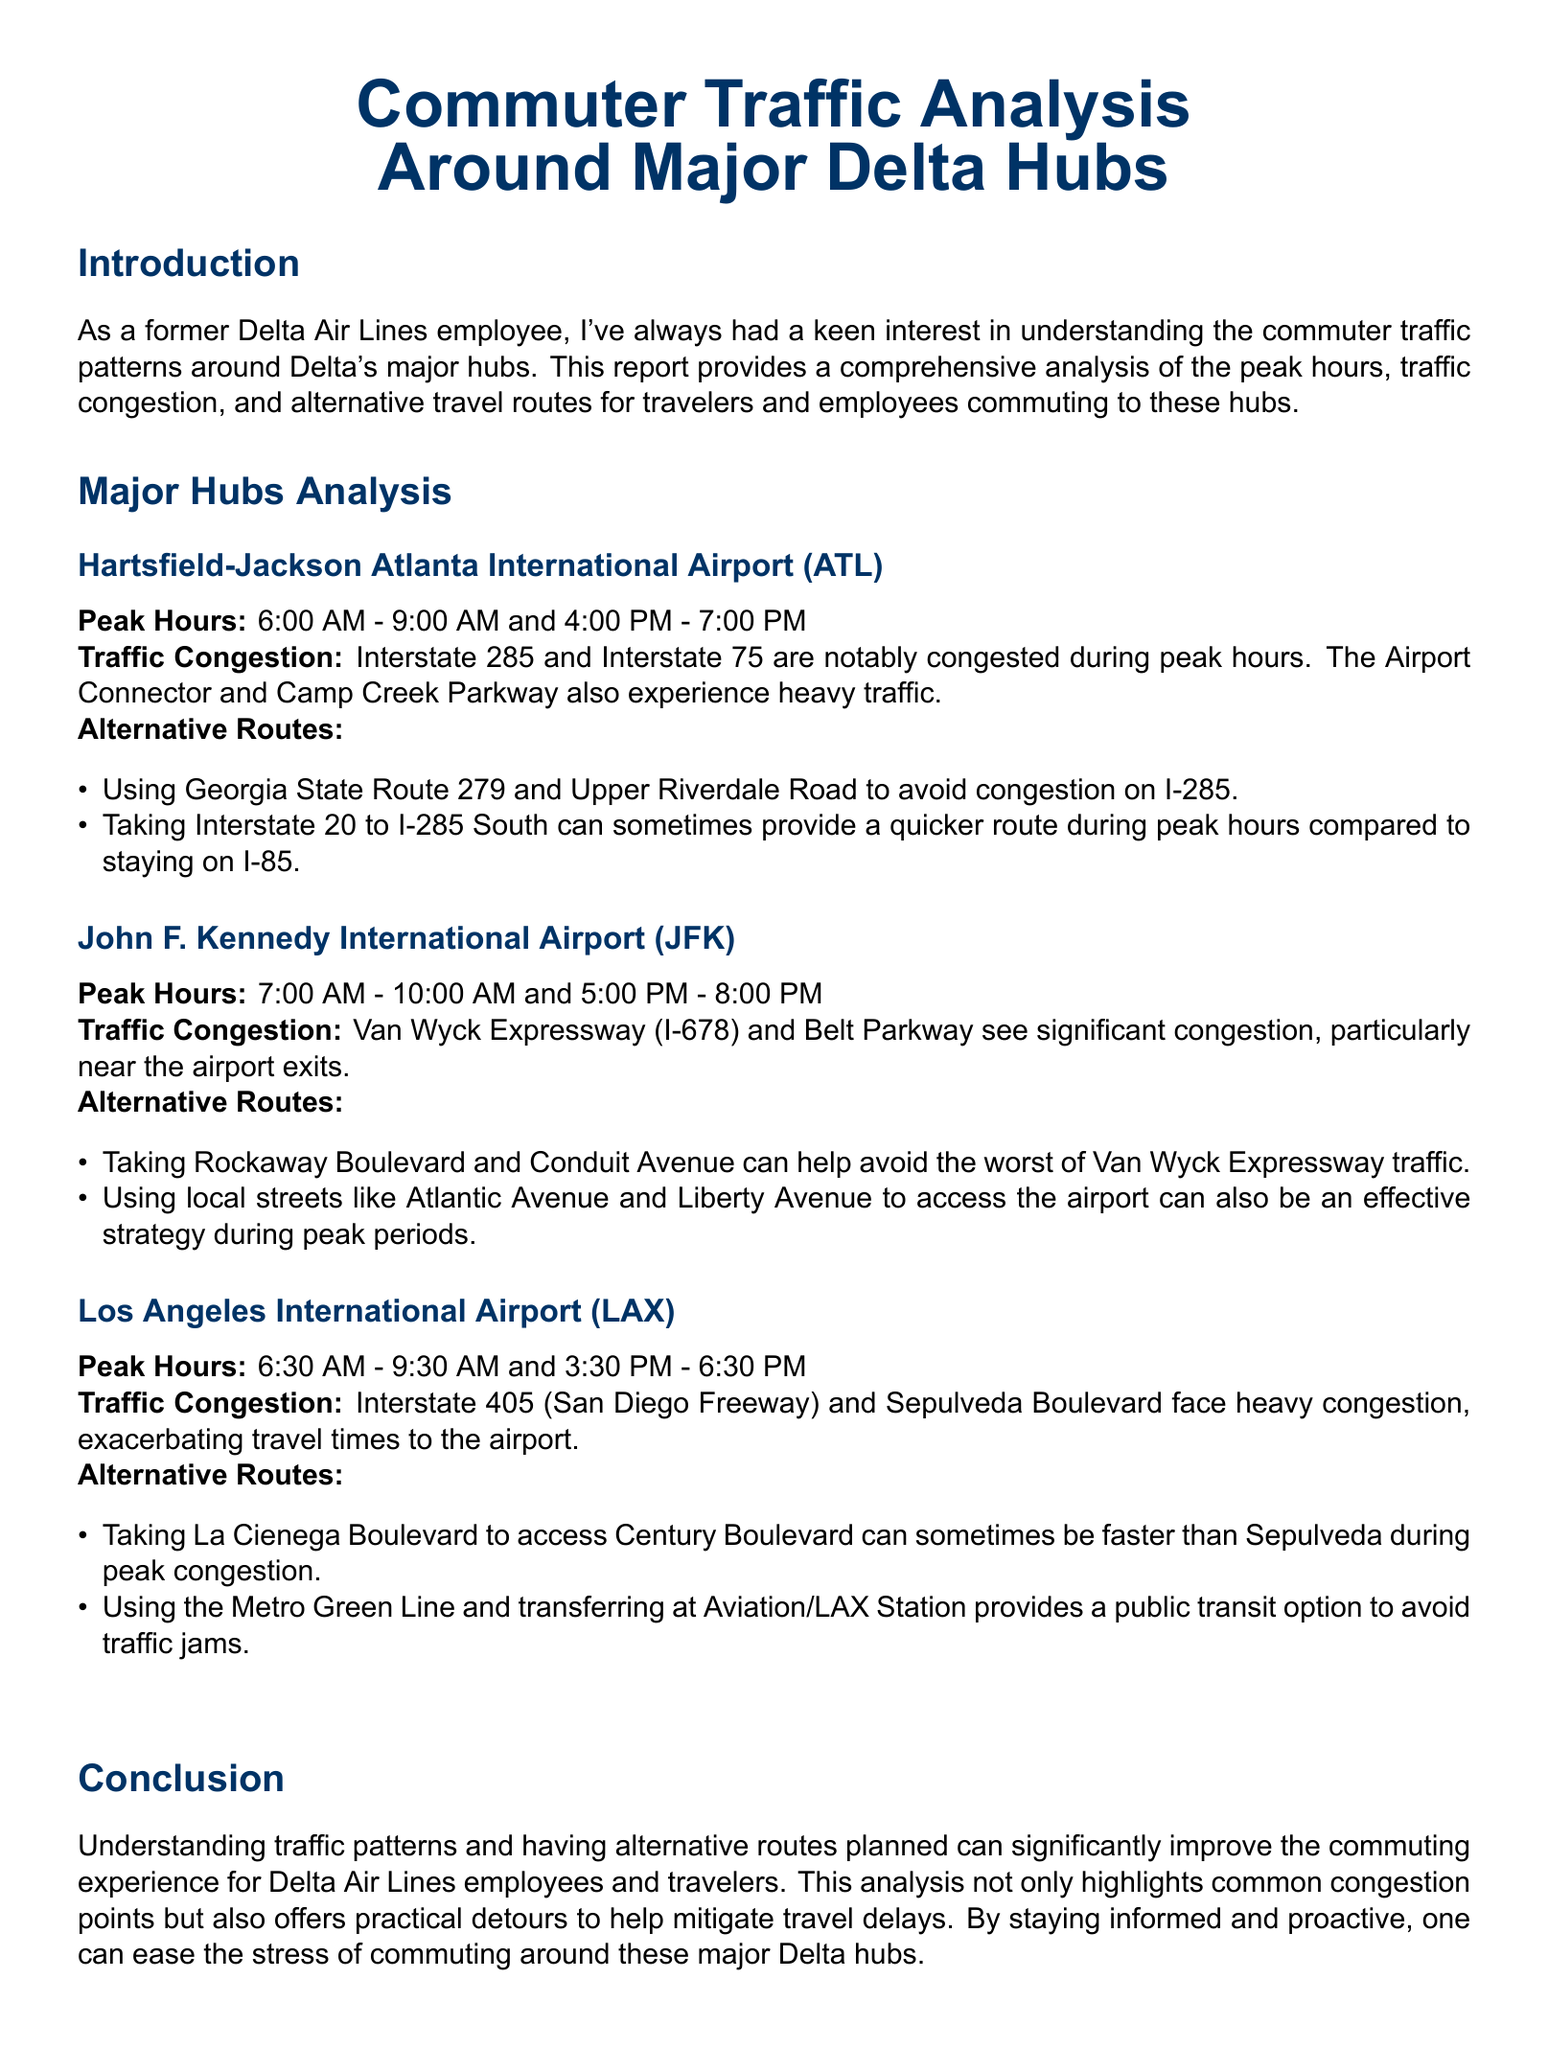What are the peak hours for ATL? The peak hours for Hartsfield-Jackson Atlanta International Airport (ATL) are 6:00 AM - 9:00 AM and 4:00 PM - 7:00 PM.
Answer: 6:00 AM - 9:00 AM and 4:00 PM - 7:00 PM Which interstate experiences congestion during peak hours at ATL? Interstate 285 and Interstate 75 are notably congested during peak hours at ATL.
Answer: Interstate 285 and Interstate 75 What alternative route can be taken to avoid congestion on I-285? Using Georgia State Route 279 and Upper Riverdale Road to avoid congestion on I-285 is suggested.
Answer: Georgia State Route 279 and Upper Riverdale Road What is the congestion pattern at JFK during peak hours? The Van Wyck Expressway (I-678) and Belt Parkway see significant congestion, particularly near the airport exits.
Answer: Van Wyck Expressway and Belt Parkway What transportation option can help avoid traffic jams to LAX? Using the Metro Green Line and transferring at Aviation/LAX Station provides a public transit option to avoid traffic jams.
Answer: Metro Green Line Which time frame is noted as peak hours for LAX? The peak hours for Los Angeles International Airport (LAX) are 6:30 AM - 9:30 AM and 3:30 PM - 6:30 PM.
Answer: 6:30 AM - 9:30 AM and 3:30 PM - 6:30 PM How does understanding traffic patterns benefit Delta employees? Understanding traffic patterns can significantly improve the commuting experience for Delta Air Lines employees.
Answer: It improves the commuting experience What local streets can be used to access JFK to avoid traffic? Using local streets like Atlantic Avenue and Liberty Avenue to access JFK can be effective.
Answer: Atlantic Avenue and Liberty Avenue 